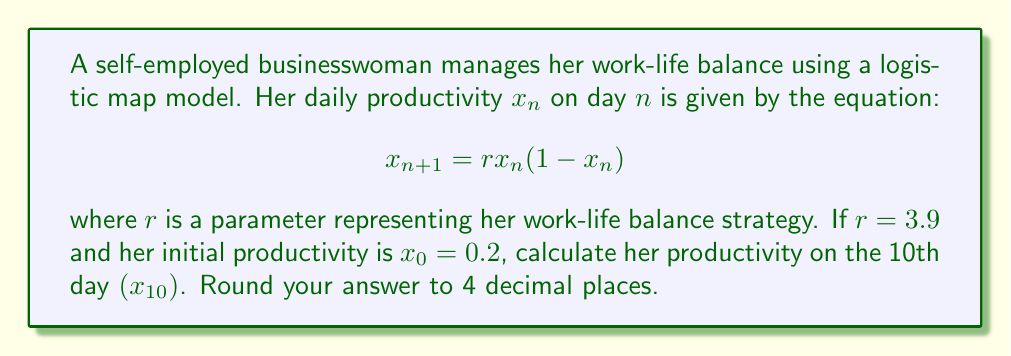Could you help me with this problem? To solve this problem, we need to iterate the logistic map equation 10 times:

1) Start with $x_0 = 0.2$ and $r = 3.9$

2) Calculate $x_1$:
   $x_1 = 3.9 * 0.2 * (1 - 0.2) = 0.624$

3) Calculate $x_2$:
   $x_2 = 3.9 * 0.624 * (1 - 0.624) = 0.9165$

4) Calculate $x_3$:
   $x_3 = 3.9 * 0.9165 * (1 - 0.9165) = 0.2988$

5) Continue this process for $x_4$ through $x_9$

6) Calculate $x_{10}$:
   $x_{10} = 3.9 * x_9 * (1 - x_9)$

Using a calculator or computer program to iterate quickly:

$x_4 = 0.8187$
$x_5 = 0.5793$
$x_6 = 0.9501$
$x_7 = 0.1847$
$x_8 = 0.5863$
$x_9 = 0.9452$
$x_{10} = 0.2017$

7) Round the result to 4 decimal places: 0.2017
Answer: 0.2017 